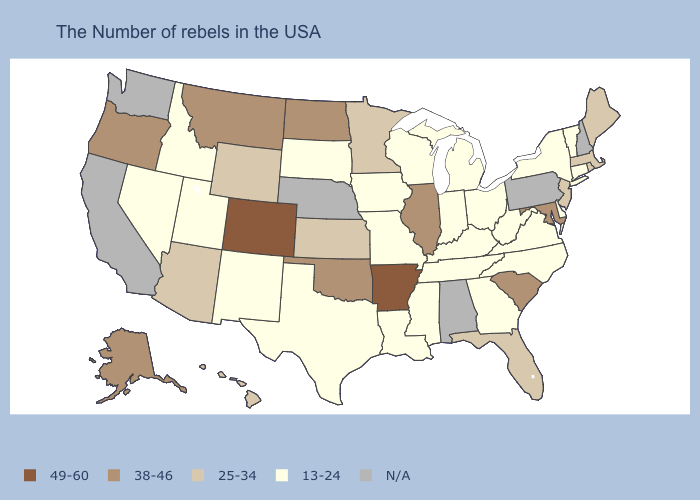Which states have the lowest value in the USA?
Give a very brief answer. Vermont, Connecticut, New York, Delaware, Virginia, North Carolina, West Virginia, Ohio, Georgia, Michigan, Kentucky, Indiana, Tennessee, Wisconsin, Mississippi, Louisiana, Missouri, Iowa, Texas, South Dakota, New Mexico, Utah, Idaho, Nevada. Name the states that have a value in the range 13-24?
Short answer required. Vermont, Connecticut, New York, Delaware, Virginia, North Carolina, West Virginia, Ohio, Georgia, Michigan, Kentucky, Indiana, Tennessee, Wisconsin, Mississippi, Louisiana, Missouri, Iowa, Texas, South Dakota, New Mexico, Utah, Idaho, Nevada. Name the states that have a value in the range 25-34?
Write a very short answer. Maine, Massachusetts, Rhode Island, New Jersey, Florida, Minnesota, Kansas, Wyoming, Arizona, Hawaii. Name the states that have a value in the range N/A?
Write a very short answer. New Hampshire, Pennsylvania, Alabama, Nebraska, California, Washington. What is the value of Indiana?
Be succinct. 13-24. Name the states that have a value in the range 49-60?
Concise answer only. Arkansas, Colorado. Name the states that have a value in the range 38-46?
Give a very brief answer. Maryland, South Carolina, Illinois, Oklahoma, North Dakota, Montana, Oregon, Alaska. Among the states that border Pennsylvania , which have the highest value?
Write a very short answer. Maryland. What is the value of South Carolina?
Give a very brief answer. 38-46. Among the states that border Connecticut , which have the lowest value?
Answer briefly. New York. What is the value of Nevada?
Write a very short answer. 13-24. Among the states that border Texas , does Arkansas have the highest value?
Write a very short answer. Yes. Which states have the highest value in the USA?
Short answer required. Arkansas, Colorado. 